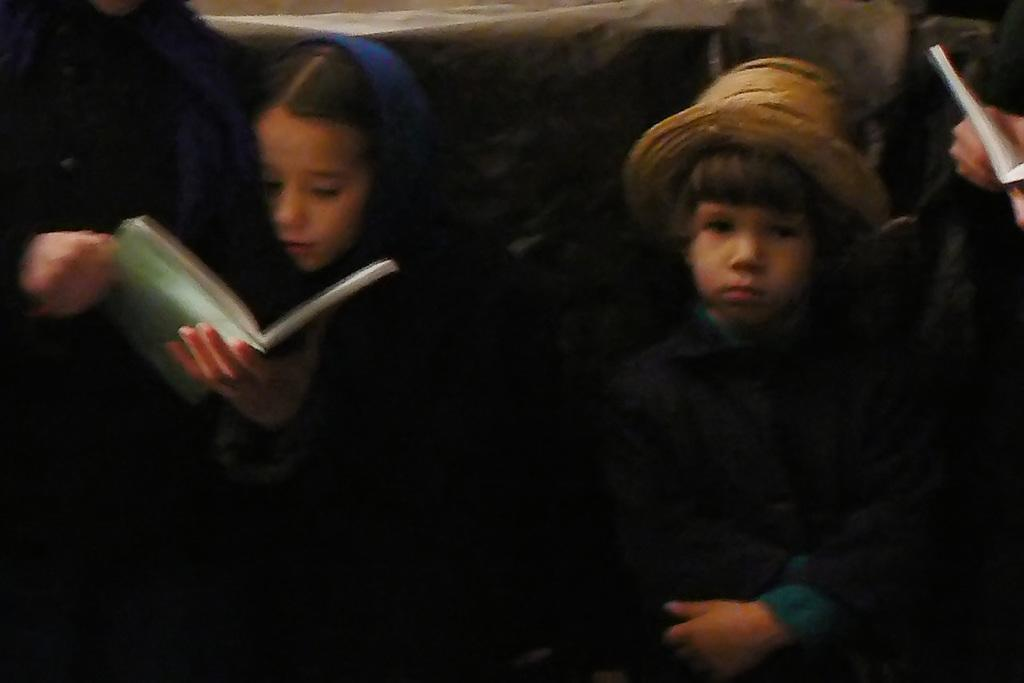How many kids are in the image? There are two kids in the center of the image. What can be seen on the right side of the image? There are people on the right side of the image, including a person holding a book. Can you describe the person on the left side of the image? There is a person holding a book on the left side of the image. What type of bridge can be seen in the image? There is no bridge present in the image. Is there a sink visible in the image? There is no sink present in the image. 